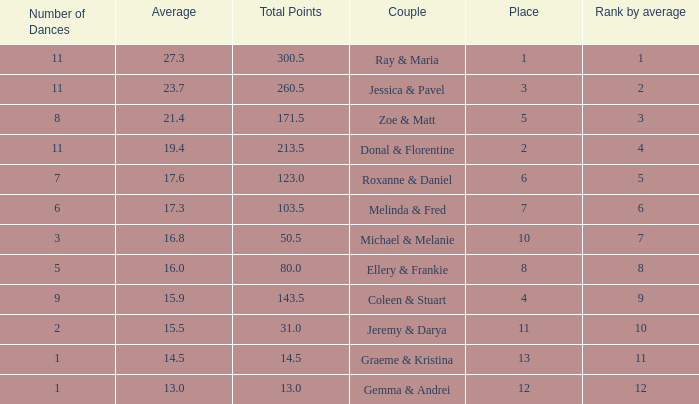If the total points is 50.5, what is the total number of dances? 1.0. 